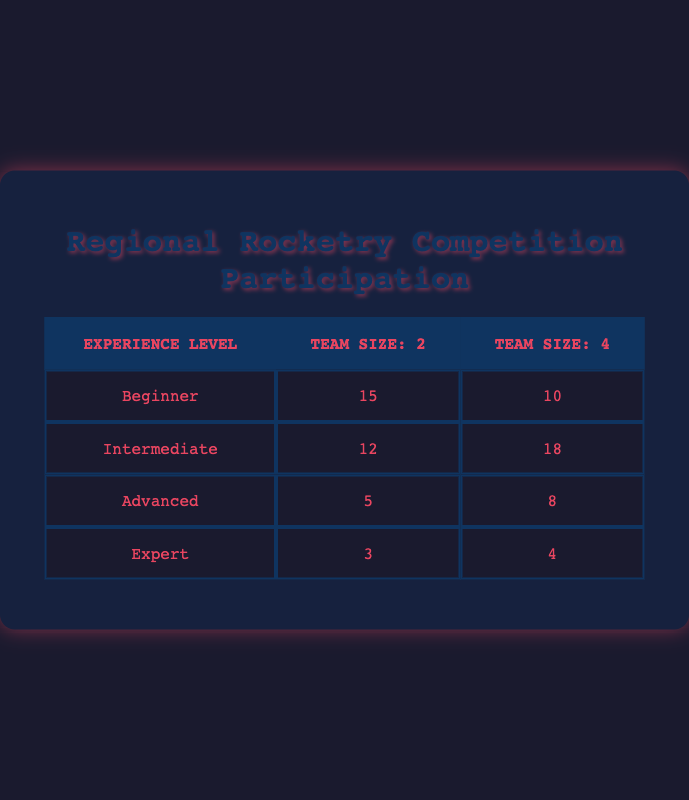What is the participation count for Beginner teams with a team size of 2? According to the table, for Beginner teams, the participation count listed under team size of 2 is 15.
Answer: 15 Which experience level had the highest participation with a team size of 4? By comparing the participation counts for team sizes of 4 across all experience levels, Intermediate shows the highest participation count at 18.
Answer: Intermediate What is the total participation count for Advanced teams regardless of team size? Adding the participation counts for Advanced teams: 5 (team size of 2) + 8 (team size of 4) = 13.
Answer: 13 Is it true that Expert teams had more participation than Beginner teams with a team size of 2? Checking the values, Expert teams had a participation count of 3, while Beginner teams had a count of 15. Since 3 is less than 15, the statement is false.
Answer: No What is the difference in participation count between team sizes 2 and 4 for Intermediate teams? The participation count for Intermediate teams is 12 for team size of 2 and 18 for team size of 4. The difference is 18 - 12 = 6.
Answer: 6 How many total participants were there from Beginner and Advanced teams with a team size of 4? Looking at the team size of 4, Beginner has 10 and Advanced has 8. Summing these figures gives 10 + 8 = 18.
Answer: 18 Was there any participation from Expert teams with a team size of 2? The table indicates that Expert teams had a participation count of 3 for team size of 2. Thus, there was participation.
Answer: Yes What is the average participation count for all experience levels with team size of 2? The sum of participation counts for team size of 2 is 15 (Beginner) + 12 (Intermediate) + 5 (Advanced) + 3 (Expert) = 35. There are 4 experience levels, so the average is 35 / 4 = 8.75.
Answer: 8.75 